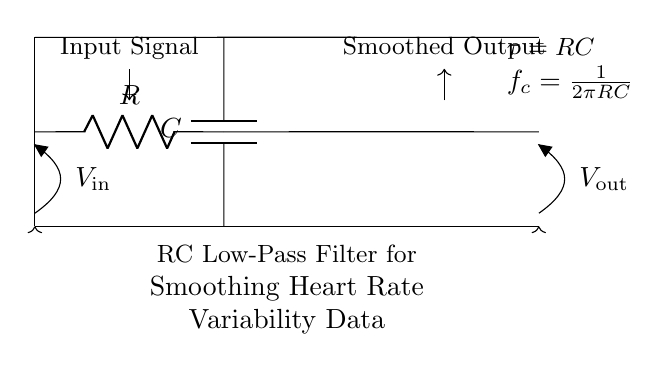What is the input signal represented by in the circuit? The input signal is represented by the voltage labeled V_in on the left side of the circuit diagram, indicating the voltage supplied to the circuit.
Answer: V_in What are the components used in this RC low-pass filter? The components used in the circuit are a resistor (labeled R) and a capacitor (labeled C) connected in a specific arrangement, where the resistor is connected in series with the capacitor.
Answer: Resistor and Capacitor What is the output voltage from the circuit? The output voltage is the voltage labeled as V_out on the right side of the circuit, indicating the voltage measured at that point after the filtering process.
Answer: V_out What is the significance of the time constant in this circuit? The time constant, denoted as tau (τ) and calculated as the product of resistance (R) and capacitance (C), indicates the time it takes for the output voltage to rise or fall to approximately 63.2% of its final value when a step input is applied.
Answer: tau How is the cutoff frequency calculated in this circuit? The cutoff frequency (f_c) is calculated using the formula f_c = 1 divided by (2π multiplied by R multiplied by C). This frequency determines the point at which signals higher than f_c are attenuated.
Answer: 1/(2πRC) What happens to high-frequency signals in this circuit? High-frequency signals are significantly attenuated by the RC low-pass filter, meaning they have reduced amplitude at the output V_out, allowing mainly the low-frequency components to pass through effectively.
Answer: Attenuated What is the role of the capacitor in this RC low-pass filter? The capacitor acts to store charge, providing a smoothing effect on the voltage signal, which helps to reduce fluctuations in the output caused by high-frequency noise in the input signal.
Answer: Smoothing 